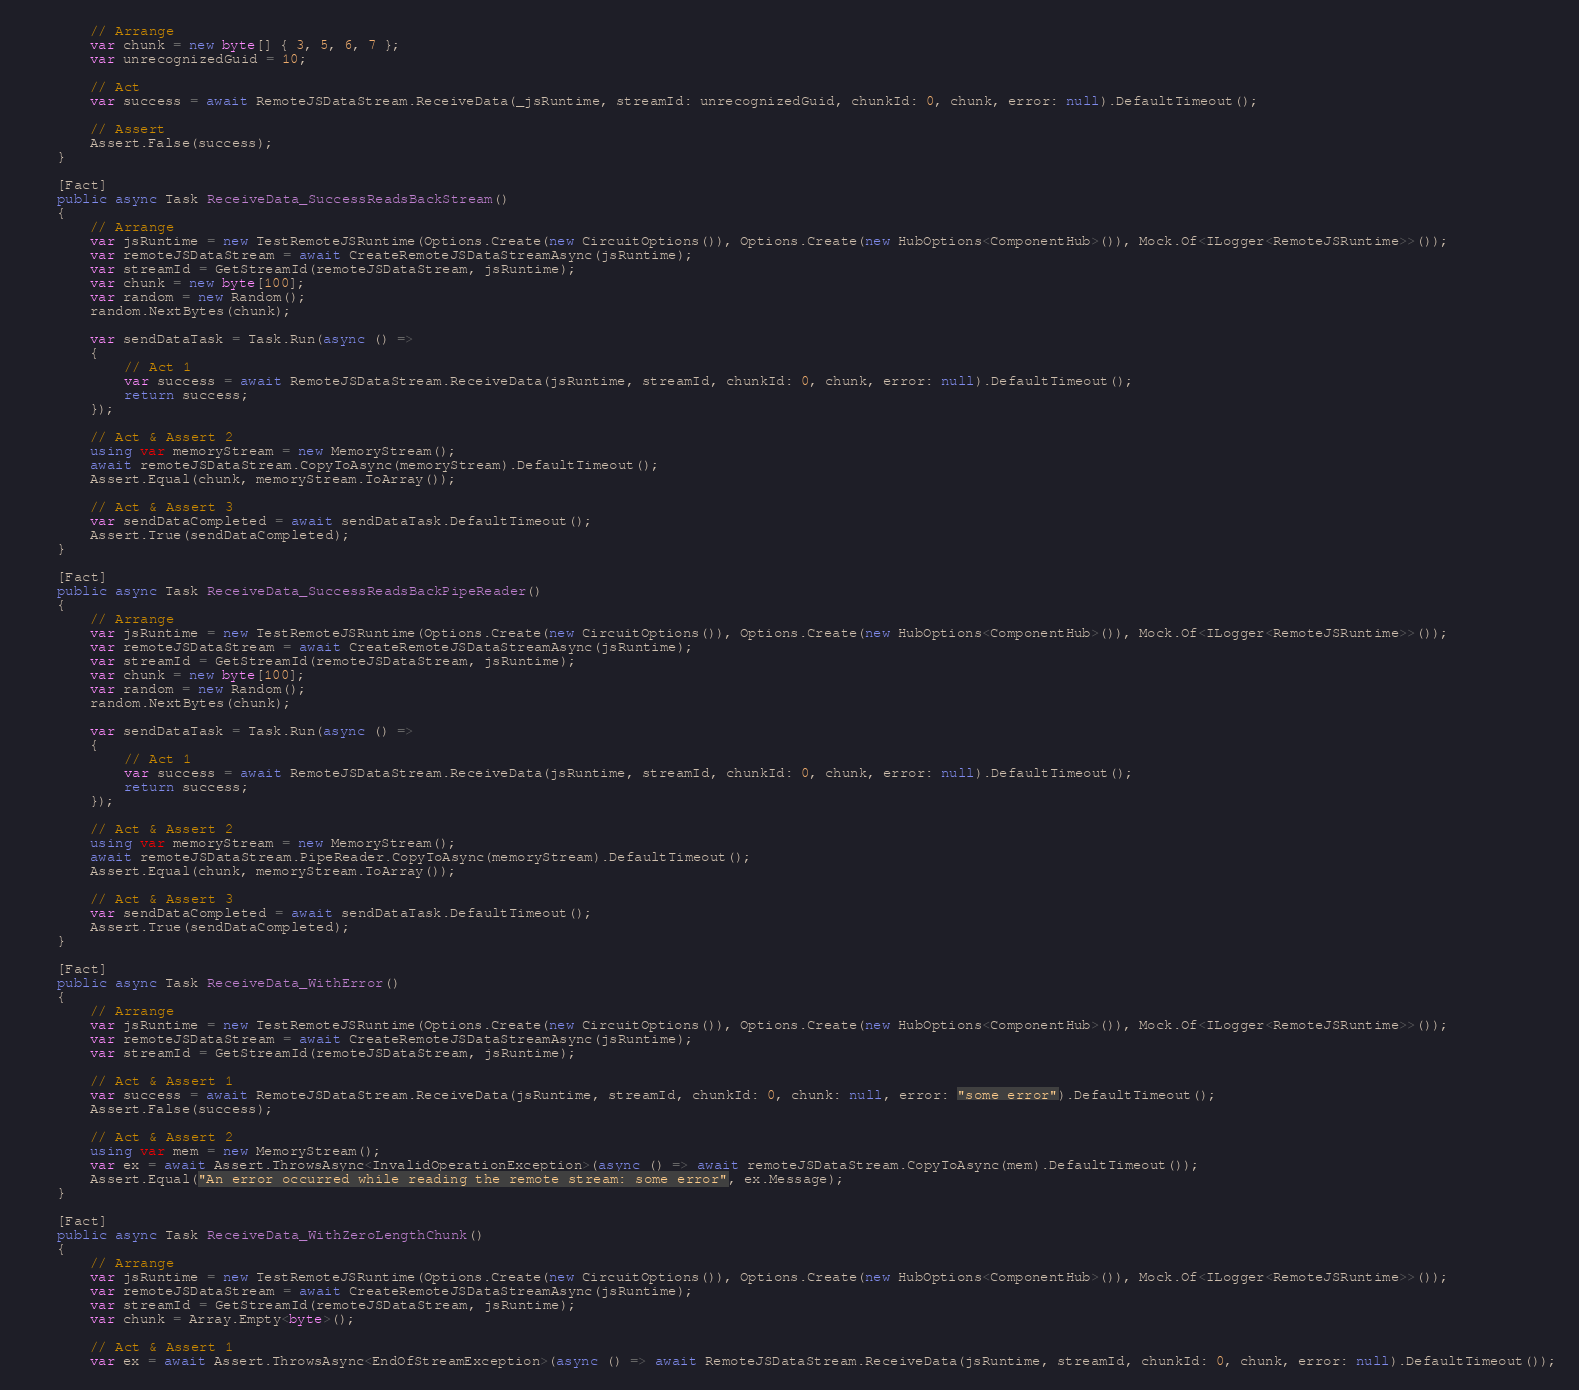Convert code to text. <code><loc_0><loc_0><loc_500><loc_500><_C#_>        // Arrange
        var chunk = new byte[] { 3, 5, 6, 7 };
        var unrecognizedGuid = 10;

        // Act
        var success = await RemoteJSDataStream.ReceiveData(_jsRuntime, streamId: unrecognizedGuid, chunkId: 0, chunk, error: null).DefaultTimeout();

        // Assert
        Assert.False(success);
    }

    [Fact]
    public async Task ReceiveData_SuccessReadsBackStream()
    {
        // Arrange
        var jsRuntime = new TestRemoteJSRuntime(Options.Create(new CircuitOptions()), Options.Create(new HubOptions<ComponentHub>()), Mock.Of<ILogger<RemoteJSRuntime>>());
        var remoteJSDataStream = await CreateRemoteJSDataStreamAsync(jsRuntime);
        var streamId = GetStreamId(remoteJSDataStream, jsRuntime);
        var chunk = new byte[100];
        var random = new Random();
        random.NextBytes(chunk);

        var sendDataTask = Task.Run(async () =>
        {
            // Act 1
            var success = await RemoteJSDataStream.ReceiveData(jsRuntime, streamId, chunkId: 0, chunk, error: null).DefaultTimeout();
            return success;
        });

        // Act & Assert 2
        using var memoryStream = new MemoryStream();
        await remoteJSDataStream.CopyToAsync(memoryStream).DefaultTimeout();
        Assert.Equal(chunk, memoryStream.ToArray());

        // Act & Assert 3
        var sendDataCompleted = await sendDataTask.DefaultTimeout();
        Assert.True(sendDataCompleted);
    }

    [Fact]
    public async Task ReceiveData_SuccessReadsBackPipeReader()
    {
        // Arrange
        var jsRuntime = new TestRemoteJSRuntime(Options.Create(new CircuitOptions()), Options.Create(new HubOptions<ComponentHub>()), Mock.Of<ILogger<RemoteJSRuntime>>());
        var remoteJSDataStream = await CreateRemoteJSDataStreamAsync(jsRuntime);
        var streamId = GetStreamId(remoteJSDataStream, jsRuntime);
        var chunk = new byte[100];
        var random = new Random();
        random.NextBytes(chunk);

        var sendDataTask = Task.Run(async () =>
        {
            // Act 1
            var success = await RemoteJSDataStream.ReceiveData(jsRuntime, streamId, chunkId: 0, chunk, error: null).DefaultTimeout();
            return success;
        });

        // Act & Assert 2
        using var memoryStream = new MemoryStream();
        await remoteJSDataStream.PipeReader.CopyToAsync(memoryStream).DefaultTimeout();
        Assert.Equal(chunk, memoryStream.ToArray());

        // Act & Assert 3
        var sendDataCompleted = await sendDataTask.DefaultTimeout();
        Assert.True(sendDataCompleted);
    }

    [Fact]
    public async Task ReceiveData_WithError()
    {
        // Arrange
        var jsRuntime = new TestRemoteJSRuntime(Options.Create(new CircuitOptions()), Options.Create(new HubOptions<ComponentHub>()), Mock.Of<ILogger<RemoteJSRuntime>>());
        var remoteJSDataStream = await CreateRemoteJSDataStreamAsync(jsRuntime);
        var streamId = GetStreamId(remoteJSDataStream, jsRuntime);

        // Act & Assert 1
        var success = await RemoteJSDataStream.ReceiveData(jsRuntime, streamId, chunkId: 0, chunk: null, error: "some error").DefaultTimeout();
        Assert.False(success);

        // Act & Assert 2
        using var mem = new MemoryStream();
        var ex = await Assert.ThrowsAsync<InvalidOperationException>(async () => await remoteJSDataStream.CopyToAsync(mem).DefaultTimeout());
        Assert.Equal("An error occurred while reading the remote stream: some error", ex.Message);
    }

    [Fact]
    public async Task ReceiveData_WithZeroLengthChunk()
    {
        // Arrange
        var jsRuntime = new TestRemoteJSRuntime(Options.Create(new CircuitOptions()), Options.Create(new HubOptions<ComponentHub>()), Mock.Of<ILogger<RemoteJSRuntime>>());
        var remoteJSDataStream = await CreateRemoteJSDataStreamAsync(jsRuntime);
        var streamId = GetStreamId(remoteJSDataStream, jsRuntime);
        var chunk = Array.Empty<byte>();

        // Act & Assert 1
        var ex = await Assert.ThrowsAsync<EndOfStreamException>(async () => await RemoteJSDataStream.ReceiveData(jsRuntime, streamId, chunkId: 0, chunk, error: null).DefaultTimeout());</code> 